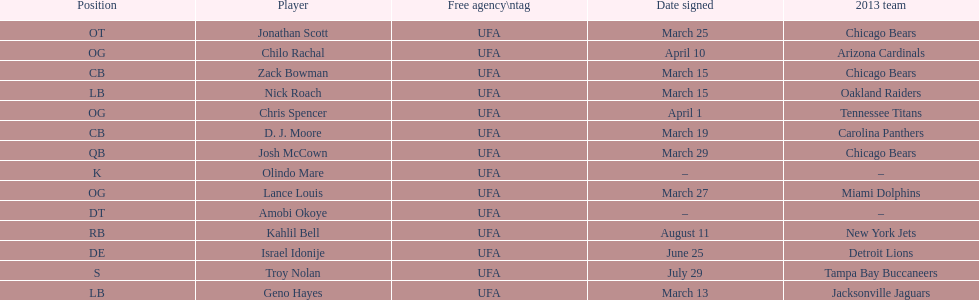Last name is also a first name beginning with "n" Troy Nolan. 